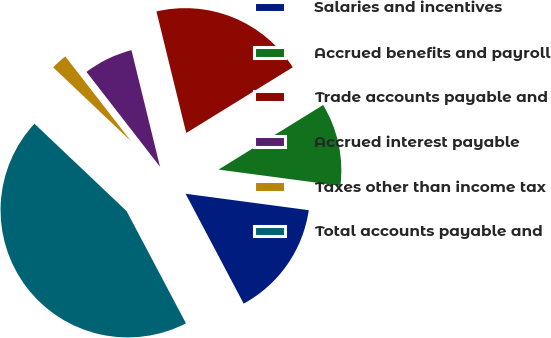Convert chart. <chart><loc_0><loc_0><loc_500><loc_500><pie_chart><fcel>Salaries and incentives<fcel>Accrued benefits and payroll<fcel>Trade accounts payable and<fcel>Accrued interest payable<fcel>Taxes other than income tax<fcel>Total accounts payable and<nl><fcel>15.15%<fcel>10.91%<fcel>20.03%<fcel>6.67%<fcel>2.43%<fcel>44.83%<nl></chart> 